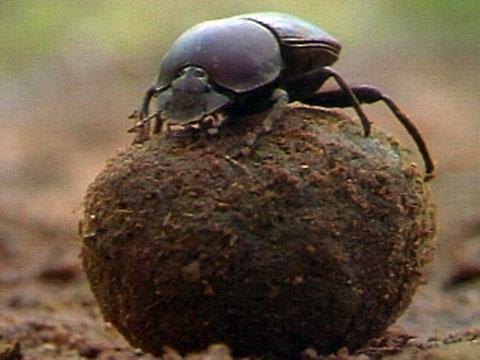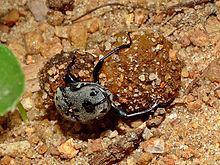The first image is the image on the left, the second image is the image on the right. Analyze the images presented: Is the assertion "A beetle is turned toward the left side of the photo in both images." valid? Answer yes or no. No. The first image is the image on the left, the second image is the image on the right. For the images shown, is this caption "One beetle sits on the top of the clod of dirt in the image on the left." true? Answer yes or no. Yes. The first image is the image on the left, the second image is the image on the right. For the images displayed, is the sentence "A beetle is perched on a ball with its front legs touching the ground on the right side of the image." factually correct? Answer yes or no. No. The first image is the image on the left, the second image is the image on the right. For the images displayed, is the sentence "Both images show beetles on dung balls with their bodies in the same general pose and location." factually correct? Answer yes or no. No. The first image is the image on the left, the second image is the image on the right. Assess this claim about the two images: "One image includes a beetle that is not in contact with a ball shape.". Correct or not? Answer yes or no. No. The first image is the image on the left, the second image is the image on the right. Examine the images to the left and right. Is the description "The image on the left contains two insects." accurate? Answer yes or no. No. The first image is the image on the left, the second image is the image on the right. Analyze the images presented: Is the assertion "Two beetles are on a blue ball." valid? Answer yes or no. No. 